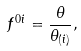Convert formula to latex. <formula><loc_0><loc_0><loc_500><loc_500>f ^ { 0 i } = \frac { \theta } { \theta _ { ( i ) } } ,</formula> 